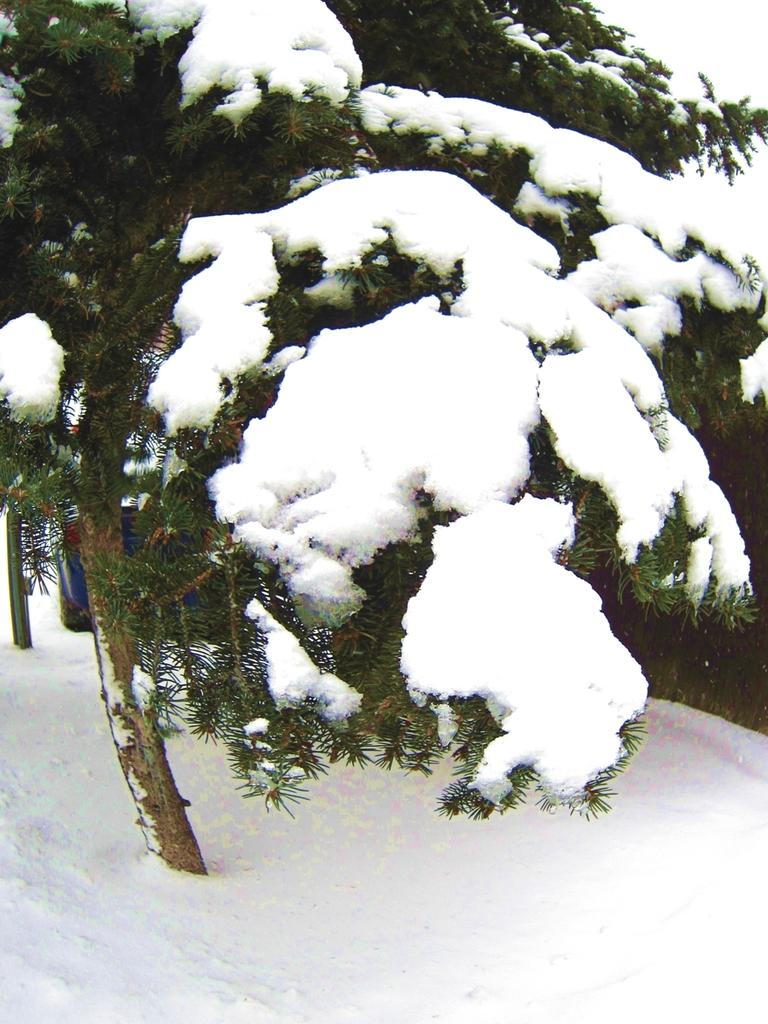What is the main object in the image? There is a tree in the image. What is the condition of the tree? The tree is covered with snow. Can you describe anything in the background of the image? There is a vehicle visible in the background of the image. How many stitches are required to repair the tree in the image? There is no need to repair the tree in the image, as it is covered with snow. Additionally, trees do not require stitches for repair. 